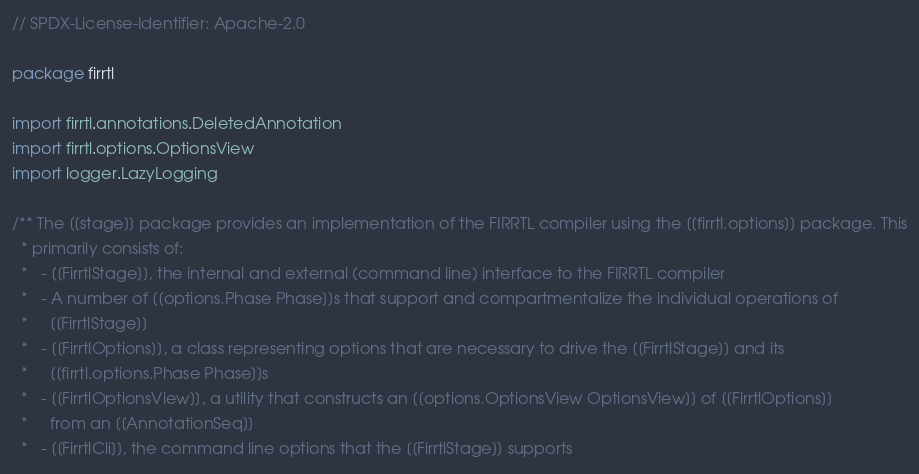<code> <loc_0><loc_0><loc_500><loc_500><_Scala_>// SPDX-License-Identifier: Apache-2.0

package firrtl

import firrtl.annotations.DeletedAnnotation
import firrtl.options.OptionsView
import logger.LazyLogging

/** The [[stage]] package provides an implementation of the FIRRTL compiler using the [[firrtl.options]] package. This
  * primarily consists of:
  *   - [[FirrtlStage]], the internal and external (command line) interface to the FIRRTL compiler
  *   - A number of [[options.Phase Phase]]s that support and compartmentalize the individual operations of
  *     [[FirrtlStage]]
  *   - [[FirrtlOptions]], a class representing options that are necessary to drive the [[FirrtlStage]] and its
  *     [[firrtl.options.Phase Phase]]s
  *   - [[FirrtlOptionsView]], a utility that constructs an [[options.OptionsView OptionsView]] of [[FirrtlOptions]]
  *     from an [[AnnotationSeq]]
  *   - [[FirrtlCli]], the command line options that the [[FirrtlStage]] supports</code> 